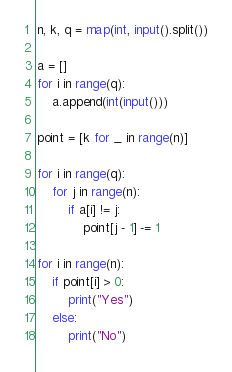Convert code to text. <code><loc_0><loc_0><loc_500><loc_500><_Python_>n, k, q = map(int, input().split())

a = []
for i in range(q):
    a.append(int(input()))

point = [k for _ in range(n)]

for i in range(q):
    for j in range(n):
        if a[i] != j:
            point[j - 1] -= 1

for i in range(n):
    if point[i] > 0:
        print("Yes")
    else:
        print("No")</code> 